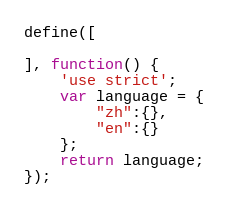Convert code to text. <code><loc_0><loc_0><loc_500><loc_500><_JavaScript_>define([
  
], function() {
    'use strict';
    var language = {
        "zh":{},
        "en":{}
    };
    return language;
});
</code> 